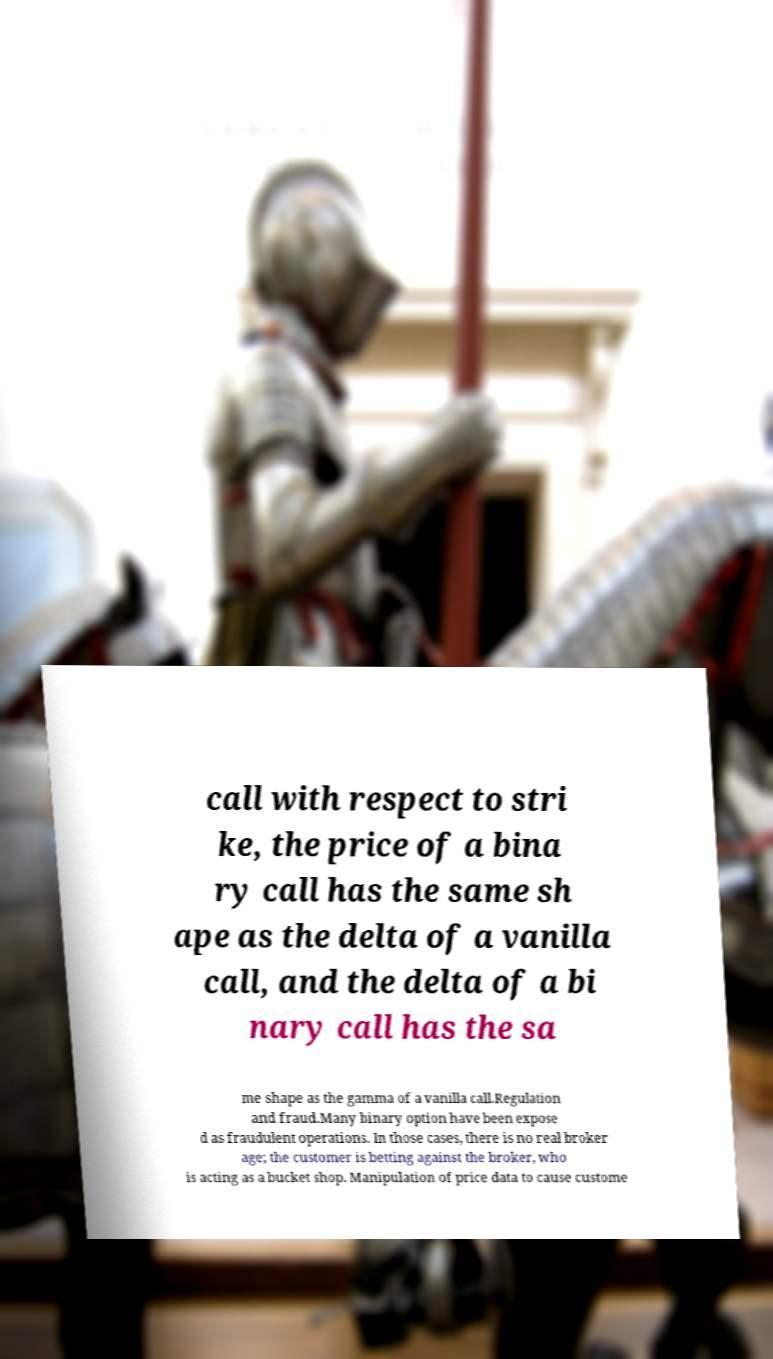I need the written content from this picture converted into text. Can you do that? call with respect to stri ke, the price of a bina ry call has the same sh ape as the delta of a vanilla call, and the delta of a bi nary call has the sa me shape as the gamma of a vanilla call.Regulation and fraud.Many binary option have been expose d as fraudulent operations. In those cases, there is no real broker age; the customer is betting against the broker, who is acting as a bucket shop. Manipulation of price data to cause custome 